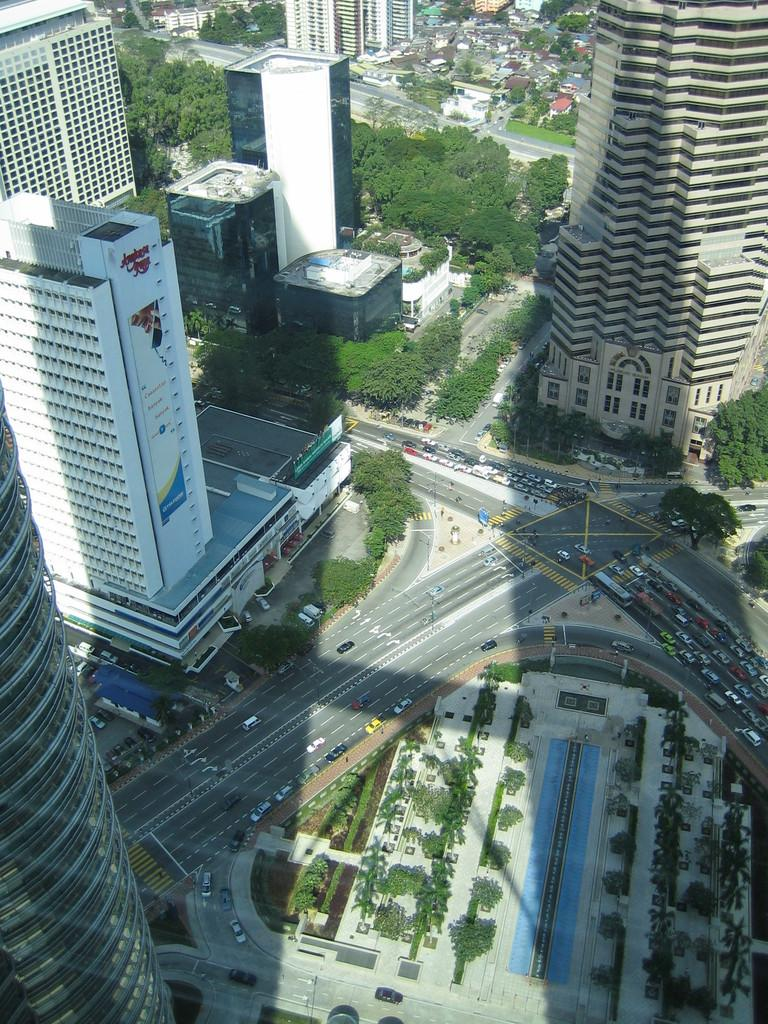What can be seen on the road in the image? There is a group of vehicles on the road in the image. What type of natural elements are visible in the image? There are trees visible in the image. What type of infrastructure is present in the image? Electric poles are present in the image. What type of man-made structures are visible in the image? There are buildings in the image. Can you describe any other objects present in the image? There are some unspecified objects in the image. What type of property is listed for sale in the image? There is no property listed for sale in the image; it features a group of vehicles on the road, trees, electric poles, buildings, and unspecified objects. Can you tell me how many bottles are visible in the image? There are no bottles present in the image. 